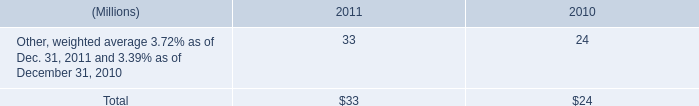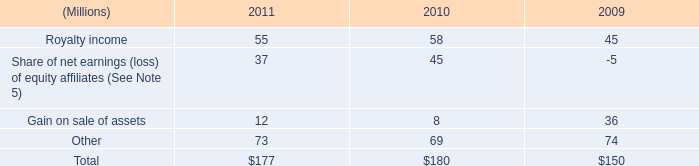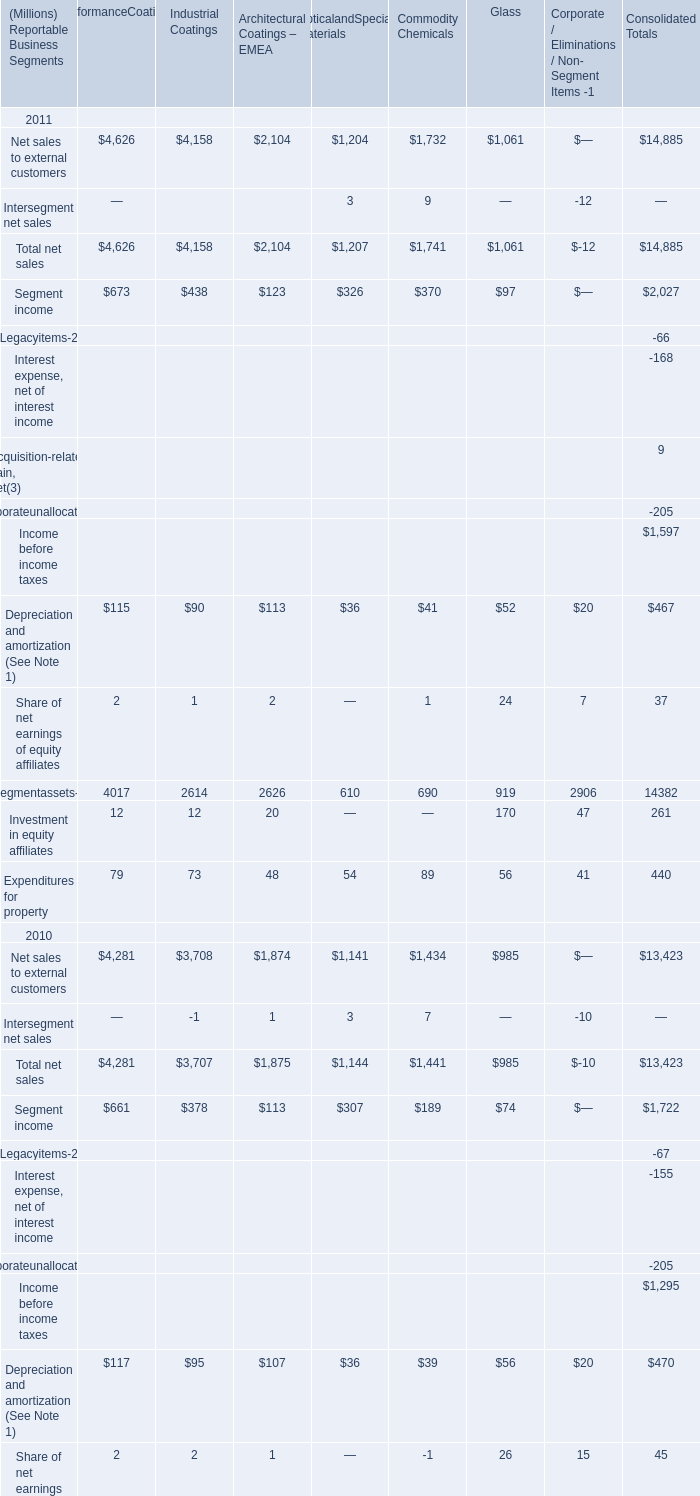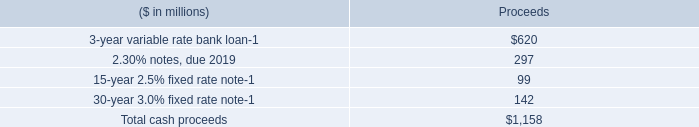what was the increase for the maximum company match on january 1 , 2011? 
Computations: ((75% * 6%) - (50% * 6%))
Answer: 0.015. 